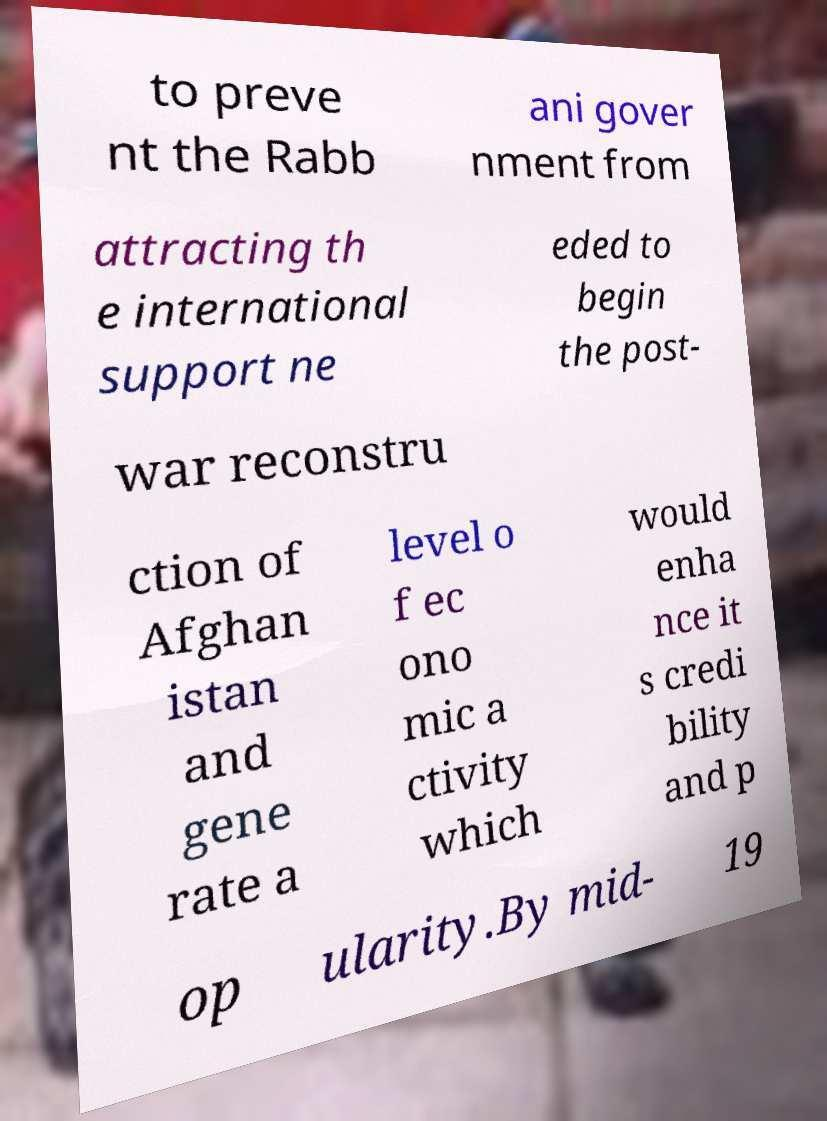Could you extract and type out the text from this image? to preve nt the Rabb ani gover nment from attracting th e international support ne eded to begin the post- war reconstru ction of Afghan istan and gene rate a level o f ec ono mic a ctivity which would enha nce it s credi bility and p op ularity.By mid- 19 